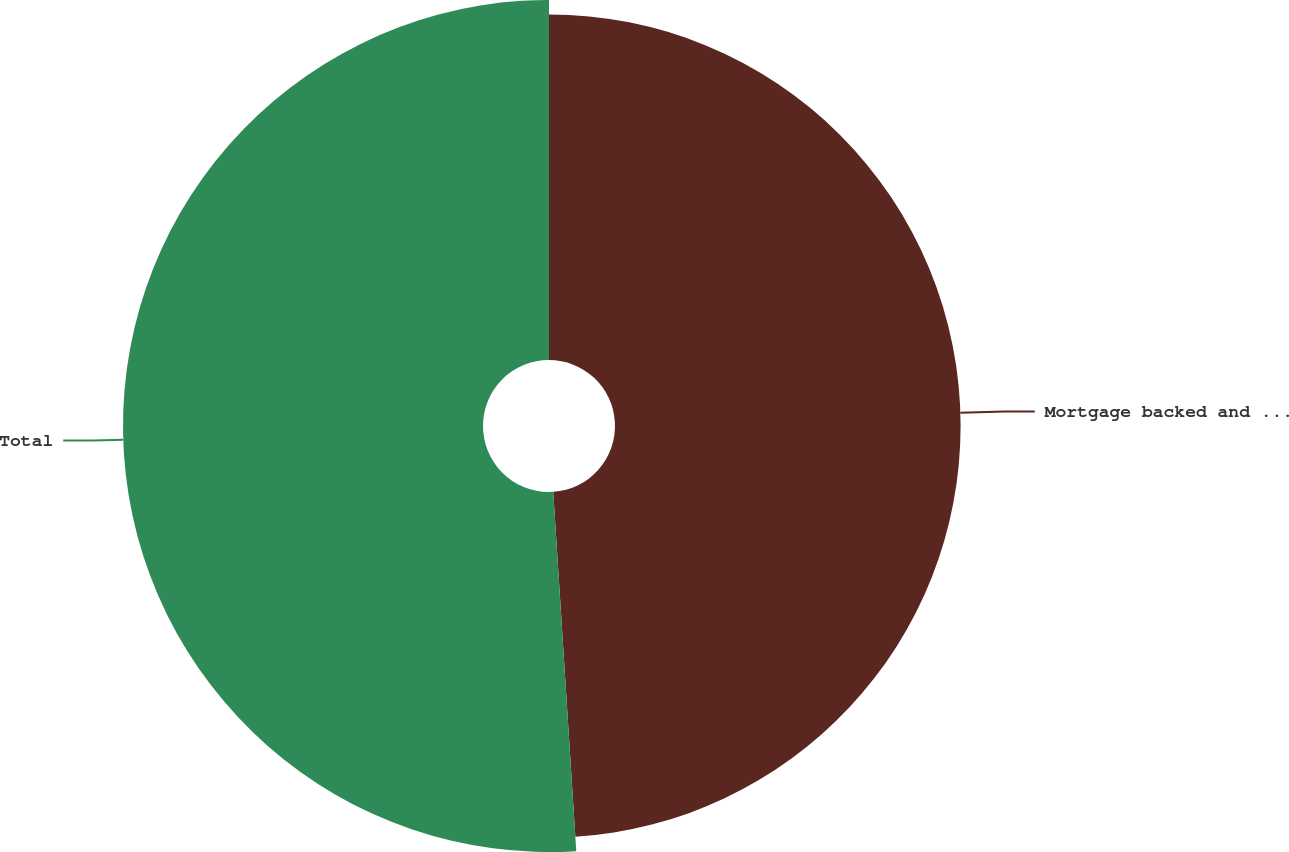<chart> <loc_0><loc_0><loc_500><loc_500><pie_chart><fcel>Mortgage backed and asset<fcel>Total<nl><fcel>48.98%<fcel>51.02%<nl></chart> 